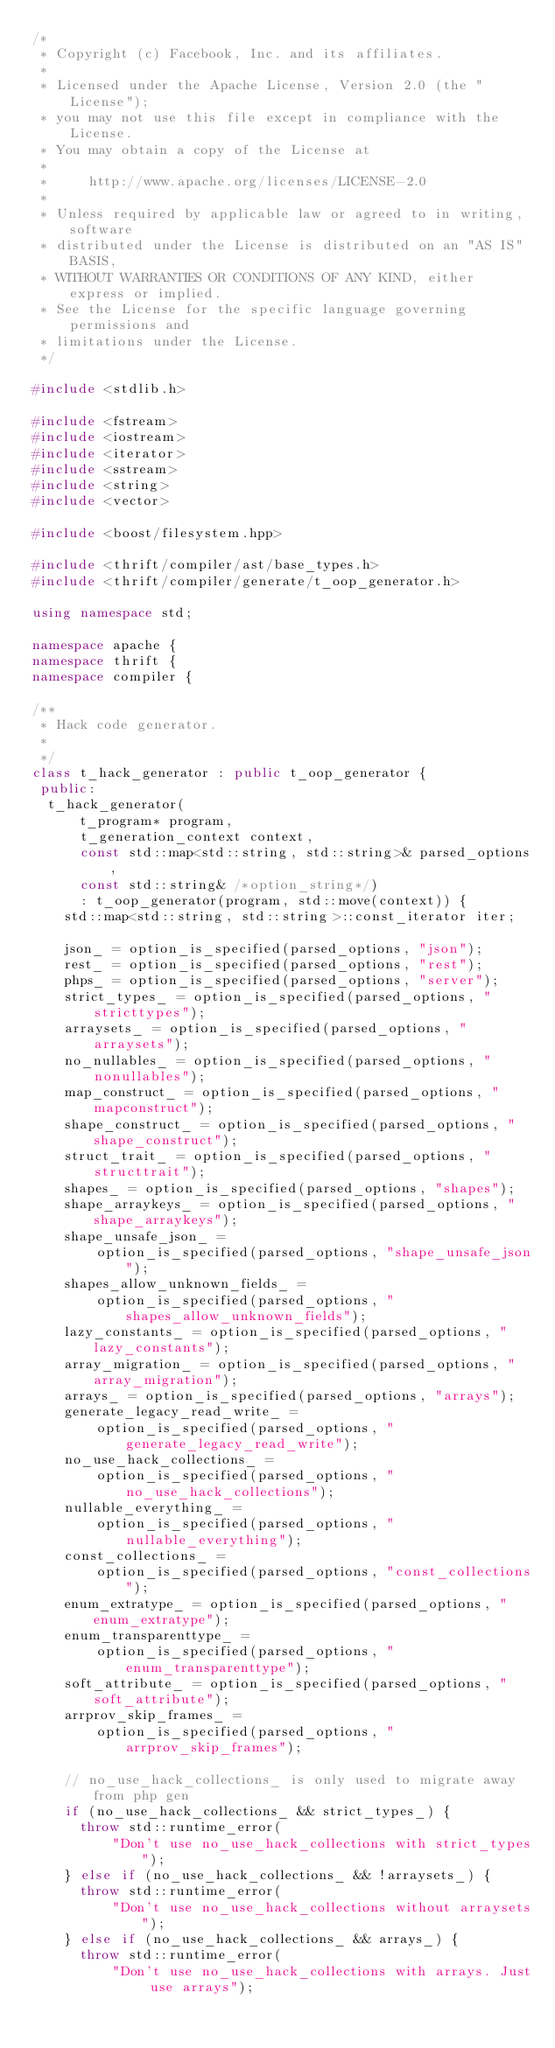Convert code to text. <code><loc_0><loc_0><loc_500><loc_500><_C++_>/*
 * Copyright (c) Facebook, Inc. and its affiliates.
 *
 * Licensed under the Apache License, Version 2.0 (the "License");
 * you may not use this file except in compliance with the License.
 * You may obtain a copy of the License at
 *
 *     http://www.apache.org/licenses/LICENSE-2.0
 *
 * Unless required by applicable law or agreed to in writing, software
 * distributed under the License is distributed on an "AS IS" BASIS,
 * WITHOUT WARRANTIES OR CONDITIONS OF ANY KIND, either express or implied.
 * See the License for the specific language governing permissions and
 * limitations under the License.
 */

#include <stdlib.h>

#include <fstream>
#include <iostream>
#include <iterator>
#include <sstream>
#include <string>
#include <vector>

#include <boost/filesystem.hpp>

#include <thrift/compiler/ast/base_types.h>
#include <thrift/compiler/generate/t_oop_generator.h>

using namespace std;

namespace apache {
namespace thrift {
namespace compiler {

/**
 * Hack code generator.
 *
 */
class t_hack_generator : public t_oop_generator {
 public:
  t_hack_generator(
      t_program* program,
      t_generation_context context,
      const std::map<std::string, std::string>& parsed_options,
      const std::string& /*option_string*/)
      : t_oop_generator(program, std::move(context)) {
    std::map<std::string, std::string>::const_iterator iter;

    json_ = option_is_specified(parsed_options, "json");
    rest_ = option_is_specified(parsed_options, "rest");
    phps_ = option_is_specified(parsed_options, "server");
    strict_types_ = option_is_specified(parsed_options, "stricttypes");
    arraysets_ = option_is_specified(parsed_options, "arraysets");
    no_nullables_ = option_is_specified(parsed_options, "nonullables");
    map_construct_ = option_is_specified(parsed_options, "mapconstruct");
    shape_construct_ = option_is_specified(parsed_options, "shape_construct");
    struct_trait_ = option_is_specified(parsed_options, "structtrait");
    shapes_ = option_is_specified(parsed_options, "shapes");
    shape_arraykeys_ = option_is_specified(parsed_options, "shape_arraykeys");
    shape_unsafe_json_ =
        option_is_specified(parsed_options, "shape_unsafe_json");
    shapes_allow_unknown_fields_ =
        option_is_specified(parsed_options, "shapes_allow_unknown_fields");
    lazy_constants_ = option_is_specified(parsed_options, "lazy_constants");
    array_migration_ = option_is_specified(parsed_options, "array_migration");
    arrays_ = option_is_specified(parsed_options, "arrays");
    generate_legacy_read_write_ =
        option_is_specified(parsed_options, "generate_legacy_read_write");
    no_use_hack_collections_ =
        option_is_specified(parsed_options, "no_use_hack_collections");
    nullable_everything_ =
        option_is_specified(parsed_options, "nullable_everything");
    const_collections_ =
        option_is_specified(parsed_options, "const_collections");
    enum_extratype_ = option_is_specified(parsed_options, "enum_extratype");
    enum_transparenttype_ =
        option_is_specified(parsed_options, "enum_transparenttype");
    soft_attribute_ = option_is_specified(parsed_options, "soft_attribute");
    arrprov_skip_frames_ =
        option_is_specified(parsed_options, "arrprov_skip_frames");

    // no_use_hack_collections_ is only used to migrate away from php gen
    if (no_use_hack_collections_ && strict_types_) {
      throw std::runtime_error(
          "Don't use no_use_hack_collections with strict_types");
    } else if (no_use_hack_collections_ && !arraysets_) {
      throw std::runtime_error(
          "Don't use no_use_hack_collections without arraysets");
    } else if (no_use_hack_collections_ && arrays_) {
      throw std::runtime_error(
          "Don't use no_use_hack_collections with arrays. Just use arrays");</code> 